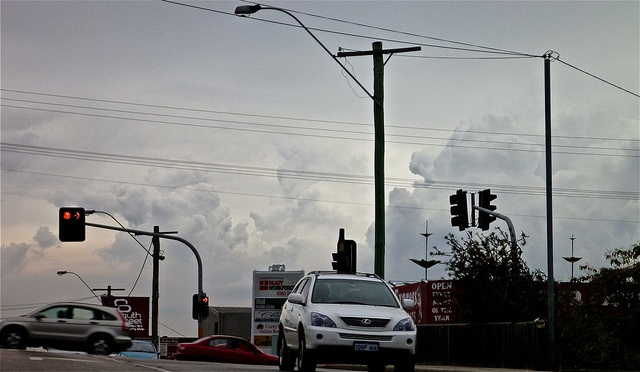Describe the objects in this image and their specific colors. I can see car in darkgray, black, gray, and purple tones, car in darkgray, black, and gray tones, car in darkgray, black, maroon, and gray tones, traffic light in darkgray, black, gray, maroon, and red tones, and traffic light in darkgray, black, gray, and lightgray tones in this image. 